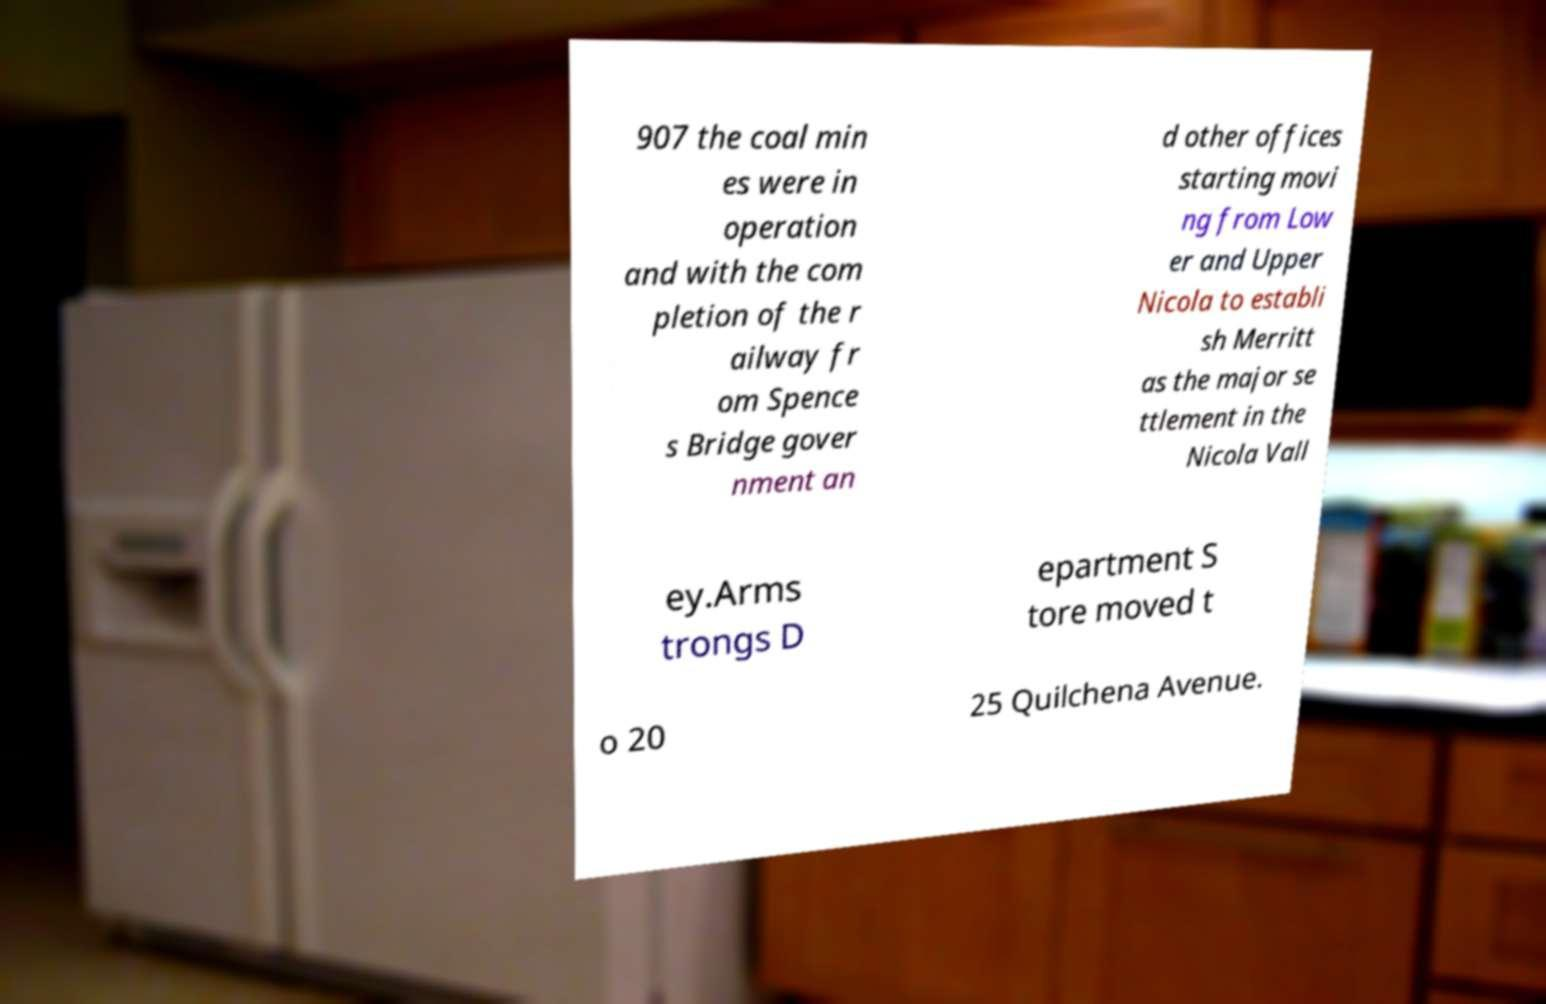For documentation purposes, I need the text within this image transcribed. Could you provide that? 907 the coal min es were in operation and with the com pletion of the r ailway fr om Spence s Bridge gover nment an d other offices starting movi ng from Low er and Upper Nicola to establi sh Merritt as the major se ttlement in the Nicola Vall ey.Arms trongs D epartment S tore moved t o 20 25 Quilchena Avenue. 